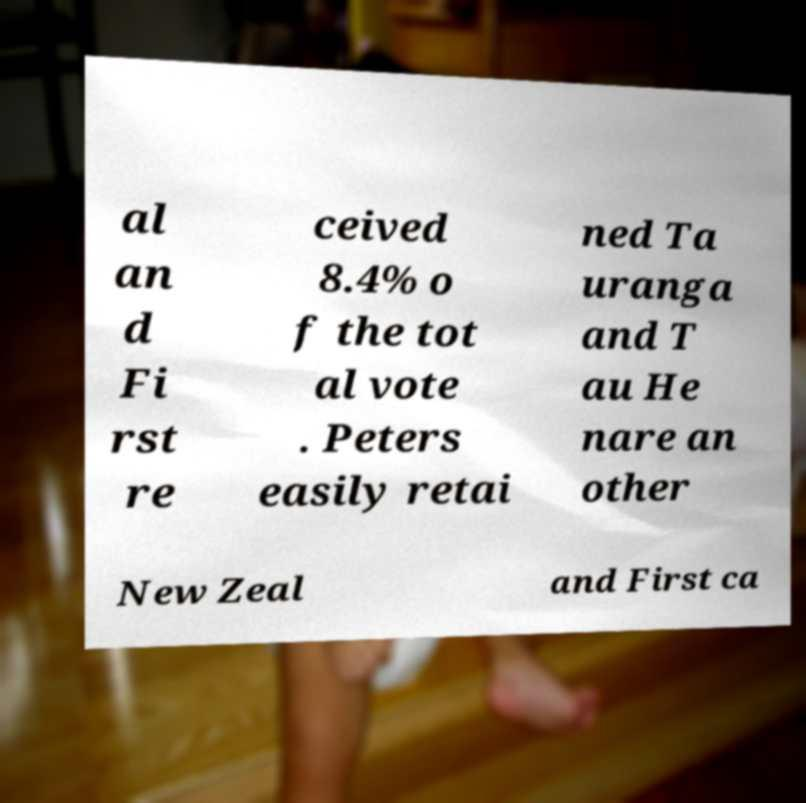Can you accurately transcribe the text from the provided image for me? al an d Fi rst re ceived 8.4% o f the tot al vote . Peters easily retai ned Ta uranga and T au He nare an other New Zeal and First ca 